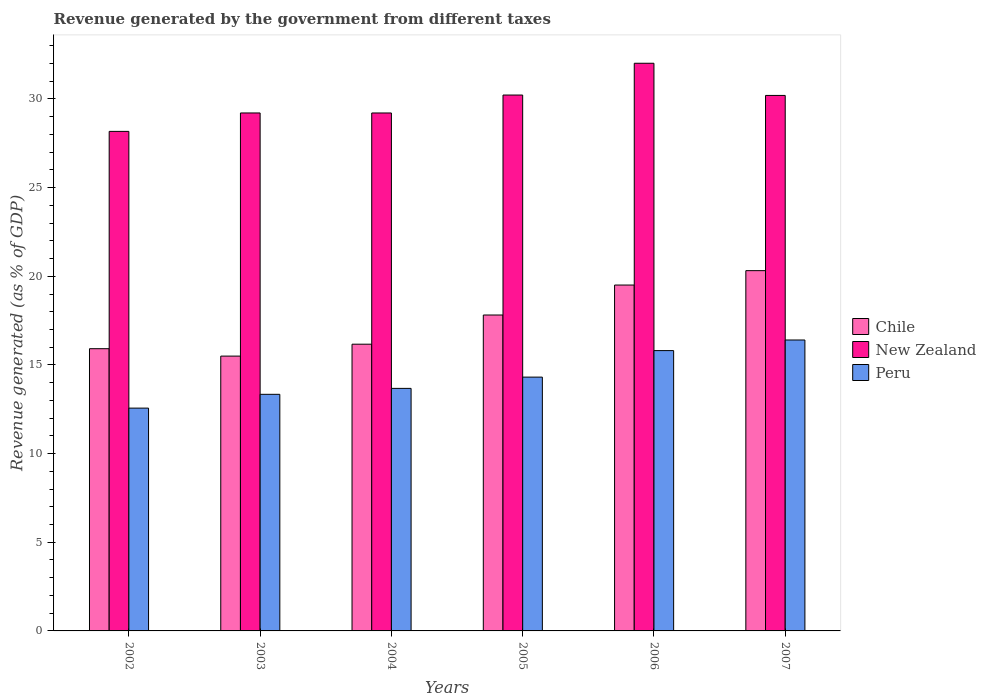Are the number of bars per tick equal to the number of legend labels?
Your answer should be compact. Yes. Are the number of bars on each tick of the X-axis equal?
Your answer should be compact. Yes. How many bars are there on the 5th tick from the right?
Ensure brevity in your answer.  3. In how many cases, is the number of bars for a given year not equal to the number of legend labels?
Keep it short and to the point. 0. What is the revenue generated by the government in New Zealand in 2005?
Offer a very short reply. 30.22. Across all years, what is the maximum revenue generated by the government in Chile?
Keep it short and to the point. 20.32. Across all years, what is the minimum revenue generated by the government in Chile?
Your answer should be very brief. 15.5. In which year was the revenue generated by the government in Chile minimum?
Offer a very short reply. 2003. What is the total revenue generated by the government in Peru in the graph?
Offer a terse response. 86.12. What is the difference between the revenue generated by the government in Peru in 2003 and that in 2005?
Your response must be concise. -0.97. What is the difference between the revenue generated by the government in Chile in 2005 and the revenue generated by the government in Peru in 2002?
Make the answer very short. 5.25. What is the average revenue generated by the government in New Zealand per year?
Your answer should be compact. 29.84. In the year 2002, what is the difference between the revenue generated by the government in Chile and revenue generated by the government in Peru?
Provide a succinct answer. 3.35. In how many years, is the revenue generated by the government in Peru greater than 24 %?
Keep it short and to the point. 0. What is the ratio of the revenue generated by the government in Peru in 2005 to that in 2006?
Make the answer very short. 0.91. Is the revenue generated by the government in Peru in 2003 less than that in 2005?
Your answer should be very brief. Yes. What is the difference between the highest and the second highest revenue generated by the government in New Zealand?
Ensure brevity in your answer.  1.79. What is the difference between the highest and the lowest revenue generated by the government in Peru?
Keep it short and to the point. 3.84. In how many years, is the revenue generated by the government in Peru greater than the average revenue generated by the government in Peru taken over all years?
Provide a short and direct response. 2. Is the sum of the revenue generated by the government in Peru in 2006 and 2007 greater than the maximum revenue generated by the government in New Zealand across all years?
Your response must be concise. Yes. What does the 3rd bar from the left in 2003 represents?
Ensure brevity in your answer.  Peru. What does the 1st bar from the right in 2007 represents?
Offer a very short reply. Peru. Is it the case that in every year, the sum of the revenue generated by the government in Peru and revenue generated by the government in New Zealand is greater than the revenue generated by the government in Chile?
Offer a terse response. Yes. Are the values on the major ticks of Y-axis written in scientific E-notation?
Provide a succinct answer. No. Does the graph contain any zero values?
Your answer should be compact. No. Does the graph contain grids?
Give a very brief answer. No. Where does the legend appear in the graph?
Provide a short and direct response. Center right. How many legend labels are there?
Your response must be concise. 3. What is the title of the graph?
Ensure brevity in your answer.  Revenue generated by the government from different taxes. Does "Russian Federation" appear as one of the legend labels in the graph?
Offer a very short reply. No. What is the label or title of the Y-axis?
Offer a very short reply. Revenue generated (as % of GDP). What is the Revenue generated (as % of GDP) of Chile in 2002?
Keep it short and to the point. 15.92. What is the Revenue generated (as % of GDP) of New Zealand in 2002?
Offer a terse response. 28.17. What is the Revenue generated (as % of GDP) of Peru in 2002?
Keep it short and to the point. 12.57. What is the Revenue generated (as % of GDP) of Chile in 2003?
Offer a terse response. 15.5. What is the Revenue generated (as % of GDP) of New Zealand in 2003?
Your answer should be very brief. 29.21. What is the Revenue generated (as % of GDP) of Peru in 2003?
Your answer should be compact. 13.34. What is the Revenue generated (as % of GDP) of Chile in 2004?
Provide a succinct answer. 16.17. What is the Revenue generated (as % of GDP) of New Zealand in 2004?
Provide a succinct answer. 29.21. What is the Revenue generated (as % of GDP) of Peru in 2004?
Provide a short and direct response. 13.68. What is the Revenue generated (as % of GDP) in Chile in 2005?
Provide a succinct answer. 17.82. What is the Revenue generated (as % of GDP) of New Zealand in 2005?
Provide a succinct answer. 30.22. What is the Revenue generated (as % of GDP) of Peru in 2005?
Your answer should be very brief. 14.31. What is the Revenue generated (as % of GDP) in Chile in 2006?
Make the answer very short. 19.51. What is the Revenue generated (as % of GDP) of New Zealand in 2006?
Ensure brevity in your answer.  32.01. What is the Revenue generated (as % of GDP) of Peru in 2006?
Your answer should be compact. 15.81. What is the Revenue generated (as % of GDP) of Chile in 2007?
Keep it short and to the point. 20.32. What is the Revenue generated (as % of GDP) in New Zealand in 2007?
Your answer should be very brief. 30.2. What is the Revenue generated (as % of GDP) of Peru in 2007?
Keep it short and to the point. 16.41. Across all years, what is the maximum Revenue generated (as % of GDP) in Chile?
Provide a short and direct response. 20.32. Across all years, what is the maximum Revenue generated (as % of GDP) in New Zealand?
Provide a succinct answer. 32.01. Across all years, what is the maximum Revenue generated (as % of GDP) in Peru?
Your response must be concise. 16.41. Across all years, what is the minimum Revenue generated (as % of GDP) in Chile?
Offer a terse response. 15.5. Across all years, what is the minimum Revenue generated (as % of GDP) of New Zealand?
Provide a succinct answer. 28.17. Across all years, what is the minimum Revenue generated (as % of GDP) in Peru?
Keep it short and to the point. 12.57. What is the total Revenue generated (as % of GDP) in Chile in the graph?
Give a very brief answer. 105.23. What is the total Revenue generated (as % of GDP) of New Zealand in the graph?
Provide a short and direct response. 179.03. What is the total Revenue generated (as % of GDP) in Peru in the graph?
Keep it short and to the point. 86.12. What is the difference between the Revenue generated (as % of GDP) in Chile in 2002 and that in 2003?
Your answer should be very brief. 0.42. What is the difference between the Revenue generated (as % of GDP) in New Zealand in 2002 and that in 2003?
Ensure brevity in your answer.  -1.04. What is the difference between the Revenue generated (as % of GDP) in Peru in 2002 and that in 2003?
Your answer should be compact. -0.78. What is the difference between the Revenue generated (as % of GDP) in Chile in 2002 and that in 2004?
Keep it short and to the point. -0.25. What is the difference between the Revenue generated (as % of GDP) in New Zealand in 2002 and that in 2004?
Give a very brief answer. -1.04. What is the difference between the Revenue generated (as % of GDP) of Peru in 2002 and that in 2004?
Your answer should be compact. -1.11. What is the difference between the Revenue generated (as % of GDP) of Chile in 2002 and that in 2005?
Offer a very short reply. -1.9. What is the difference between the Revenue generated (as % of GDP) in New Zealand in 2002 and that in 2005?
Keep it short and to the point. -2.05. What is the difference between the Revenue generated (as % of GDP) in Peru in 2002 and that in 2005?
Your response must be concise. -1.75. What is the difference between the Revenue generated (as % of GDP) of Chile in 2002 and that in 2006?
Your response must be concise. -3.59. What is the difference between the Revenue generated (as % of GDP) of New Zealand in 2002 and that in 2006?
Your response must be concise. -3.84. What is the difference between the Revenue generated (as % of GDP) of Peru in 2002 and that in 2006?
Make the answer very short. -3.24. What is the difference between the Revenue generated (as % of GDP) in Chile in 2002 and that in 2007?
Make the answer very short. -4.4. What is the difference between the Revenue generated (as % of GDP) of New Zealand in 2002 and that in 2007?
Your answer should be very brief. -2.03. What is the difference between the Revenue generated (as % of GDP) in Peru in 2002 and that in 2007?
Your response must be concise. -3.84. What is the difference between the Revenue generated (as % of GDP) of Chile in 2003 and that in 2004?
Your answer should be very brief. -0.67. What is the difference between the Revenue generated (as % of GDP) in New Zealand in 2003 and that in 2004?
Provide a succinct answer. 0. What is the difference between the Revenue generated (as % of GDP) in Peru in 2003 and that in 2004?
Your answer should be very brief. -0.34. What is the difference between the Revenue generated (as % of GDP) in Chile in 2003 and that in 2005?
Provide a succinct answer. -2.32. What is the difference between the Revenue generated (as % of GDP) of New Zealand in 2003 and that in 2005?
Offer a very short reply. -1.01. What is the difference between the Revenue generated (as % of GDP) in Peru in 2003 and that in 2005?
Offer a very short reply. -0.97. What is the difference between the Revenue generated (as % of GDP) in Chile in 2003 and that in 2006?
Offer a very short reply. -4.01. What is the difference between the Revenue generated (as % of GDP) of New Zealand in 2003 and that in 2006?
Your response must be concise. -2.8. What is the difference between the Revenue generated (as % of GDP) in Peru in 2003 and that in 2006?
Provide a short and direct response. -2.47. What is the difference between the Revenue generated (as % of GDP) of Chile in 2003 and that in 2007?
Keep it short and to the point. -4.82. What is the difference between the Revenue generated (as % of GDP) of New Zealand in 2003 and that in 2007?
Ensure brevity in your answer.  -0.99. What is the difference between the Revenue generated (as % of GDP) of Peru in 2003 and that in 2007?
Your answer should be compact. -3.06. What is the difference between the Revenue generated (as % of GDP) in Chile in 2004 and that in 2005?
Provide a succinct answer. -1.65. What is the difference between the Revenue generated (as % of GDP) of New Zealand in 2004 and that in 2005?
Keep it short and to the point. -1.01. What is the difference between the Revenue generated (as % of GDP) in Peru in 2004 and that in 2005?
Give a very brief answer. -0.64. What is the difference between the Revenue generated (as % of GDP) of Chile in 2004 and that in 2006?
Offer a terse response. -3.34. What is the difference between the Revenue generated (as % of GDP) in New Zealand in 2004 and that in 2006?
Your answer should be very brief. -2.8. What is the difference between the Revenue generated (as % of GDP) in Peru in 2004 and that in 2006?
Provide a short and direct response. -2.13. What is the difference between the Revenue generated (as % of GDP) in Chile in 2004 and that in 2007?
Your response must be concise. -4.15. What is the difference between the Revenue generated (as % of GDP) in New Zealand in 2004 and that in 2007?
Give a very brief answer. -0.99. What is the difference between the Revenue generated (as % of GDP) in Peru in 2004 and that in 2007?
Your response must be concise. -2.73. What is the difference between the Revenue generated (as % of GDP) of Chile in 2005 and that in 2006?
Make the answer very short. -1.69. What is the difference between the Revenue generated (as % of GDP) in New Zealand in 2005 and that in 2006?
Provide a succinct answer. -1.79. What is the difference between the Revenue generated (as % of GDP) in Peru in 2005 and that in 2006?
Provide a short and direct response. -1.5. What is the difference between the Revenue generated (as % of GDP) of Chile in 2005 and that in 2007?
Provide a short and direct response. -2.5. What is the difference between the Revenue generated (as % of GDP) in New Zealand in 2005 and that in 2007?
Provide a short and direct response. 0.02. What is the difference between the Revenue generated (as % of GDP) of Peru in 2005 and that in 2007?
Keep it short and to the point. -2.09. What is the difference between the Revenue generated (as % of GDP) of Chile in 2006 and that in 2007?
Offer a terse response. -0.81. What is the difference between the Revenue generated (as % of GDP) in New Zealand in 2006 and that in 2007?
Make the answer very short. 1.81. What is the difference between the Revenue generated (as % of GDP) in Peru in 2006 and that in 2007?
Your answer should be very brief. -0.6. What is the difference between the Revenue generated (as % of GDP) in Chile in 2002 and the Revenue generated (as % of GDP) in New Zealand in 2003?
Make the answer very short. -13.29. What is the difference between the Revenue generated (as % of GDP) in Chile in 2002 and the Revenue generated (as % of GDP) in Peru in 2003?
Make the answer very short. 2.57. What is the difference between the Revenue generated (as % of GDP) of New Zealand in 2002 and the Revenue generated (as % of GDP) of Peru in 2003?
Offer a terse response. 14.83. What is the difference between the Revenue generated (as % of GDP) of Chile in 2002 and the Revenue generated (as % of GDP) of New Zealand in 2004?
Make the answer very short. -13.29. What is the difference between the Revenue generated (as % of GDP) of Chile in 2002 and the Revenue generated (as % of GDP) of Peru in 2004?
Give a very brief answer. 2.24. What is the difference between the Revenue generated (as % of GDP) in New Zealand in 2002 and the Revenue generated (as % of GDP) in Peru in 2004?
Keep it short and to the point. 14.49. What is the difference between the Revenue generated (as % of GDP) of Chile in 2002 and the Revenue generated (as % of GDP) of New Zealand in 2005?
Give a very brief answer. -14.31. What is the difference between the Revenue generated (as % of GDP) in Chile in 2002 and the Revenue generated (as % of GDP) in Peru in 2005?
Your answer should be compact. 1.6. What is the difference between the Revenue generated (as % of GDP) of New Zealand in 2002 and the Revenue generated (as % of GDP) of Peru in 2005?
Keep it short and to the point. 13.86. What is the difference between the Revenue generated (as % of GDP) of Chile in 2002 and the Revenue generated (as % of GDP) of New Zealand in 2006?
Your response must be concise. -16.1. What is the difference between the Revenue generated (as % of GDP) in Chile in 2002 and the Revenue generated (as % of GDP) in Peru in 2006?
Ensure brevity in your answer.  0.11. What is the difference between the Revenue generated (as % of GDP) of New Zealand in 2002 and the Revenue generated (as % of GDP) of Peru in 2006?
Give a very brief answer. 12.36. What is the difference between the Revenue generated (as % of GDP) in Chile in 2002 and the Revenue generated (as % of GDP) in New Zealand in 2007?
Provide a succinct answer. -14.28. What is the difference between the Revenue generated (as % of GDP) in Chile in 2002 and the Revenue generated (as % of GDP) in Peru in 2007?
Give a very brief answer. -0.49. What is the difference between the Revenue generated (as % of GDP) of New Zealand in 2002 and the Revenue generated (as % of GDP) of Peru in 2007?
Your answer should be compact. 11.77. What is the difference between the Revenue generated (as % of GDP) of Chile in 2003 and the Revenue generated (as % of GDP) of New Zealand in 2004?
Your response must be concise. -13.71. What is the difference between the Revenue generated (as % of GDP) of Chile in 2003 and the Revenue generated (as % of GDP) of Peru in 2004?
Provide a short and direct response. 1.82. What is the difference between the Revenue generated (as % of GDP) of New Zealand in 2003 and the Revenue generated (as % of GDP) of Peru in 2004?
Your answer should be compact. 15.53. What is the difference between the Revenue generated (as % of GDP) of Chile in 2003 and the Revenue generated (as % of GDP) of New Zealand in 2005?
Offer a very short reply. -14.72. What is the difference between the Revenue generated (as % of GDP) of Chile in 2003 and the Revenue generated (as % of GDP) of Peru in 2005?
Keep it short and to the point. 1.18. What is the difference between the Revenue generated (as % of GDP) in New Zealand in 2003 and the Revenue generated (as % of GDP) in Peru in 2005?
Offer a terse response. 14.9. What is the difference between the Revenue generated (as % of GDP) in Chile in 2003 and the Revenue generated (as % of GDP) in New Zealand in 2006?
Ensure brevity in your answer.  -16.52. What is the difference between the Revenue generated (as % of GDP) in Chile in 2003 and the Revenue generated (as % of GDP) in Peru in 2006?
Provide a succinct answer. -0.31. What is the difference between the Revenue generated (as % of GDP) of New Zealand in 2003 and the Revenue generated (as % of GDP) of Peru in 2006?
Provide a short and direct response. 13.4. What is the difference between the Revenue generated (as % of GDP) in Chile in 2003 and the Revenue generated (as % of GDP) in New Zealand in 2007?
Ensure brevity in your answer.  -14.7. What is the difference between the Revenue generated (as % of GDP) in Chile in 2003 and the Revenue generated (as % of GDP) in Peru in 2007?
Provide a succinct answer. -0.91. What is the difference between the Revenue generated (as % of GDP) in New Zealand in 2003 and the Revenue generated (as % of GDP) in Peru in 2007?
Your answer should be very brief. 12.8. What is the difference between the Revenue generated (as % of GDP) in Chile in 2004 and the Revenue generated (as % of GDP) in New Zealand in 2005?
Offer a very short reply. -14.05. What is the difference between the Revenue generated (as % of GDP) in Chile in 2004 and the Revenue generated (as % of GDP) in Peru in 2005?
Your answer should be very brief. 1.86. What is the difference between the Revenue generated (as % of GDP) in New Zealand in 2004 and the Revenue generated (as % of GDP) in Peru in 2005?
Your response must be concise. 14.9. What is the difference between the Revenue generated (as % of GDP) of Chile in 2004 and the Revenue generated (as % of GDP) of New Zealand in 2006?
Provide a short and direct response. -15.84. What is the difference between the Revenue generated (as % of GDP) in Chile in 2004 and the Revenue generated (as % of GDP) in Peru in 2006?
Your answer should be very brief. 0.36. What is the difference between the Revenue generated (as % of GDP) in New Zealand in 2004 and the Revenue generated (as % of GDP) in Peru in 2006?
Offer a terse response. 13.4. What is the difference between the Revenue generated (as % of GDP) of Chile in 2004 and the Revenue generated (as % of GDP) of New Zealand in 2007?
Offer a very short reply. -14.03. What is the difference between the Revenue generated (as % of GDP) of Chile in 2004 and the Revenue generated (as % of GDP) of Peru in 2007?
Offer a very short reply. -0.24. What is the difference between the Revenue generated (as % of GDP) in New Zealand in 2004 and the Revenue generated (as % of GDP) in Peru in 2007?
Ensure brevity in your answer.  12.8. What is the difference between the Revenue generated (as % of GDP) in Chile in 2005 and the Revenue generated (as % of GDP) in New Zealand in 2006?
Provide a succinct answer. -14.2. What is the difference between the Revenue generated (as % of GDP) in Chile in 2005 and the Revenue generated (as % of GDP) in Peru in 2006?
Provide a short and direct response. 2.01. What is the difference between the Revenue generated (as % of GDP) of New Zealand in 2005 and the Revenue generated (as % of GDP) of Peru in 2006?
Offer a very short reply. 14.41. What is the difference between the Revenue generated (as % of GDP) of Chile in 2005 and the Revenue generated (as % of GDP) of New Zealand in 2007?
Keep it short and to the point. -12.38. What is the difference between the Revenue generated (as % of GDP) of Chile in 2005 and the Revenue generated (as % of GDP) of Peru in 2007?
Offer a very short reply. 1.41. What is the difference between the Revenue generated (as % of GDP) of New Zealand in 2005 and the Revenue generated (as % of GDP) of Peru in 2007?
Make the answer very short. 13.82. What is the difference between the Revenue generated (as % of GDP) of Chile in 2006 and the Revenue generated (as % of GDP) of New Zealand in 2007?
Your answer should be compact. -10.69. What is the difference between the Revenue generated (as % of GDP) of Chile in 2006 and the Revenue generated (as % of GDP) of Peru in 2007?
Give a very brief answer. 3.1. What is the difference between the Revenue generated (as % of GDP) of New Zealand in 2006 and the Revenue generated (as % of GDP) of Peru in 2007?
Offer a terse response. 15.61. What is the average Revenue generated (as % of GDP) of Chile per year?
Provide a succinct answer. 17.54. What is the average Revenue generated (as % of GDP) in New Zealand per year?
Provide a short and direct response. 29.84. What is the average Revenue generated (as % of GDP) in Peru per year?
Ensure brevity in your answer.  14.35. In the year 2002, what is the difference between the Revenue generated (as % of GDP) in Chile and Revenue generated (as % of GDP) in New Zealand?
Your response must be concise. -12.26. In the year 2002, what is the difference between the Revenue generated (as % of GDP) of Chile and Revenue generated (as % of GDP) of Peru?
Ensure brevity in your answer.  3.35. In the year 2002, what is the difference between the Revenue generated (as % of GDP) in New Zealand and Revenue generated (as % of GDP) in Peru?
Offer a very short reply. 15.61. In the year 2003, what is the difference between the Revenue generated (as % of GDP) of Chile and Revenue generated (as % of GDP) of New Zealand?
Make the answer very short. -13.71. In the year 2003, what is the difference between the Revenue generated (as % of GDP) of Chile and Revenue generated (as % of GDP) of Peru?
Keep it short and to the point. 2.16. In the year 2003, what is the difference between the Revenue generated (as % of GDP) of New Zealand and Revenue generated (as % of GDP) of Peru?
Provide a short and direct response. 15.87. In the year 2004, what is the difference between the Revenue generated (as % of GDP) in Chile and Revenue generated (as % of GDP) in New Zealand?
Keep it short and to the point. -13.04. In the year 2004, what is the difference between the Revenue generated (as % of GDP) of Chile and Revenue generated (as % of GDP) of Peru?
Offer a very short reply. 2.49. In the year 2004, what is the difference between the Revenue generated (as % of GDP) of New Zealand and Revenue generated (as % of GDP) of Peru?
Your answer should be very brief. 15.53. In the year 2005, what is the difference between the Revenue generated (as % of GDP) in Chile and Revenue generated (as % of GDP) in New Zealand?
Offer a very short reply. -12.41. In the year 2005, what is the difference between the Revenue generated (as % of GDP) of Chile and Revenue generated (as % of GDP) of Peru?
Offer a very short reply. 3.5. In the year 2005, what is the difference between the Revenue generated (as % of GDP) in New Zealand and Revenue generated (as % of GDP) in Peru?
Your response must be concise. 15.91. In the year 2006, what is the difference between the Revenue generated (as % of GDP) in Chile and Revenue generated (as % of GDP) in New Zealand?
Make the answer very short. -12.51. In the year 2006, what is the difference between the Revenue generated (as % of GDP) of Chile and Revenue generated (as % of GDP) of Peru?
Your answer should be compact. 3.7. In the year 2006, what is the difference between the Revenue generated (as % of GDP) in New Zealand and Revenue generated (as % of GDP) in Peru?
Keep it short and to the point. 16.21. In the year 2007, what is the difference between the Revenue generated (as % of GDP) in Chile and Revenue generated (as % of GDP) in New Zealand?
Your answer should be compact. -9.88. In the year 2007, what is the difference between the Revenue generated (as % of GDP) in Chile and Revenue generated (as % of GDP) in Peru?
Your response must be concise. 3.91. In the year 2007, what is the difference between the Revenue generated (as % of GDP) of New Zealand and Revenue generated (as % of GDP) of Peru?
Your answer should be compact. 13.79. What is the ratio of the Revenue generated (as % of GDP) in Chile in 2002 to that in 2003?
Your response must be concise. 1.03. What is the ratio of the Revenue generated (as % of GDP) in New Zealand in 2002 to that in 2003?
Keep it short and to the point. 0.96. What is the ratio of the Revenue generated (as % of GDP) in Peru in 2002 to that in 2003?
Give a very brief answer. 0.94. What is the ratio of the Revenue generated (as % of GDP) of Chile in 2002 to that in 2004?
Keep it short and to the point. 0.98. What is the ratio of the Revenue generated (as % of GDP) in New Zealand in 2002 to that in 2004?
Your answer should be very brief. 0.96. What is the ratio of the Revenue generated (as % of GDP) in Peru in 2002 to that in 2004?
Your answer should be compact. 0.92. What is the ratio of the Revenue generated (as % of GDP) in Chile in 2002 to that in 2005?
Offer a terse response. 0.89. What is the ratio of the Revenue generated (as % of GDP) of New Zealand in 2002 to that in 2005?
Keep it short and to the point. 0.93. What is the ratio of the Revenue generated (as % of GDP) in Peru in 2002 to that in 2005?
Give a very brief answer. 0.88. What is the ratio of the Revenue generated (as % of GDP) in Chile in 2002 to that in 2006?
Your answer should be very brief. 0.82. What is the ratio of the Revenue generated (as % of GDP) in Peru in 2002 to that in 2006?
Ensure brevity in your answer.  0.79. What is the ratio of the Revenue generated (as % of GDP) of Chile in 2002 to that in 2007?
Provide a succinct answer. 0.78. What is the ratio of the Revenue generated (as % of GDP) of New Zealand in 2002 to that in 2007?
Your answer should be very brief. 0.93. What is the ratio of the Revenue generated (as % of GDP) of Peru in 2002 to that in 2007?
Ensure brevity in your answer.  0.77. What is the ratio of the Revenue generated (as % of GDP) in Chile in 2003 to that in 2004?
Your answer should be compact. 0.96. What is the ratio of the Revenue generated (as % of GDP) in New Zealand in 2003 to that in 2004?
Your answer should be compact. 1. What is the ratio of the Revenue generated (as % of GDP) of Peru in 2003 to that in 2004?
Offer a very short reply. 0.98. What is the ratio of the Revenue generated (as % of GDP) in Chile in 2003 to that in 2005?
Provide a short and direct response. 0.87. What is the ratio of the Revenue generated (as % of GDP) of New Zealand in 2003 to that in 2005?
Give a very brief answer. 0.97. What is the ratio of the Revenue generated (as % of GDP) in Peru in 2003 to that in 2005?
Your response must be concise. 0.93. What is the ratio of the Revenue generated (as % of GDP) of Chile in 2003 to that in 2006?
Provide a short and direct response. 0.79. What is the ratio of the Revenue generated (as % of GDP) in New Zealand in 2003 to that in 2006?
Provide a succinct answer. 0.91. What is the ratio of the Revenue generated (as % of GDP) in Peru in 2003 to that in 2006?
Ensure brevity in your answer.  0.84. What is the ratio of the Revenue generated (as % of GDP) in Chile in 2003 to that in 2007?
Your answer should be compact. 0.76. What is the ratio of the Revenue generated (as % of GDP) of New Zealand in 2003 to that in 2007?
Give a very brief answer. 0.97. What is the ratio of the Revenue generated (as % of GDP) of Peru in 2003 to that in 2007?
Offer a very short reply. 0.81. What is the ratio of the Revenue generated (as % of GDP) of Chile in 2004 to that in 2005?
Offer a very short reply. 0.91. What is the ratio of the Revenue generated (as % of GDP) of New Zealand in 2004 to that in 2005?
Your response must be concise. 0.97. What is the ratio of the Revenue generated (as % of GDP) of Peru in 2004 to that in 2005?
Your answer should be very brief. 0.96. What is the ratio of the Revenue generated (as % of GDP) of Chile in 2004 to that in 2006?
Offer a terse response. 0.83. What is the ratio of the Revenue generated (as % of GDP) of New Zealand in 2004 to that in 2006?
Provide a succinct answer. 0.91. What is the ratio of the Revenue generated (as % of GDP) in Peru in 2004 to that in 2006?
Provide a succinct answer. 0.87. What is the ratio of the Revenue generated (as % of GDP) of Chile in 2004 to that in 2007?
Give a very brief answer. 0.8. What is the ratio of the Revenue generated (as % of GDP) in New Zealand in 2004 to that in 2007?
Your answer should be very brief. 0.97. What is the ratio of the Revenue generated (as % of GDP) in Peru in 2004 to that in 2007?
Your answer should be very brief. 0.83. What is the ratio of the Revenue generated (as % of GDP) of Chile in 2005 to that in 2006?
Offer a terse response. 0.91. What is the ratio of the Revenue generated (as % of GDP) in New Zealand in 2005 to that in 2006?
Your answer should be very brief. 0.94. What is the ratio of the Revenue generated (as % of GDP) of Peru in 2005 to that in 2006?
Give a very brief answer. 0.91. What is the ratio of the Revenue generated (as % of GDP) in Chile in 2005 to that in 2007?
Make the answer very short. 0.88. What is the ratio of the Revenue generated (as % of GDP) in New Zealand in 2005 to that in 2007?
Make the answer very short. 1. What is the ratio of the Revenue generated (as % of GDP) of Peru in 2005 to that in 2007?
Your response must be concise. 0.87. What is the ratio of the Revenue generated (as % of GDP) in Chile in 2006 to that in 2007?
Make the answer very short. 0.96. What is the ratio of the Revenue generated (as % of GDP) in New Zealand in 2006 to that in 2007?
Keep it short and to the point. 1.06. What is the ratio of the Revenue generated (as % of GDP) in Peru in 2006 to that in 2007?
Ensure brevity in your answer.  0.96. What is the difference between the highest and the second highest Revenue generated (as % of GDP) of Chile?
Offer a terse response. 0.81. What is the difference between the highest and the second highest Revenue generated (as % of GDP) of New Zealand?
Ensure brevity in your answer.  1.79. What is the difference between the highest and the second highest Revenue generated (as % of GDP) of Peru?
Provide a succinct answer. 0.6. What is the difference between the highest and the lowest Revenue generated (as % of GDP) of Chile?
Your response must be concise. 4.82. What is the difference between the highest and the lowest Revenue generated (as % of GDP) of New Zealand?
Your response must be concise. 3.84. What is the difference between the highest and the lowest Revenue generated (as % of GDP) of Peru?
Offer a terse response. 3.84. 